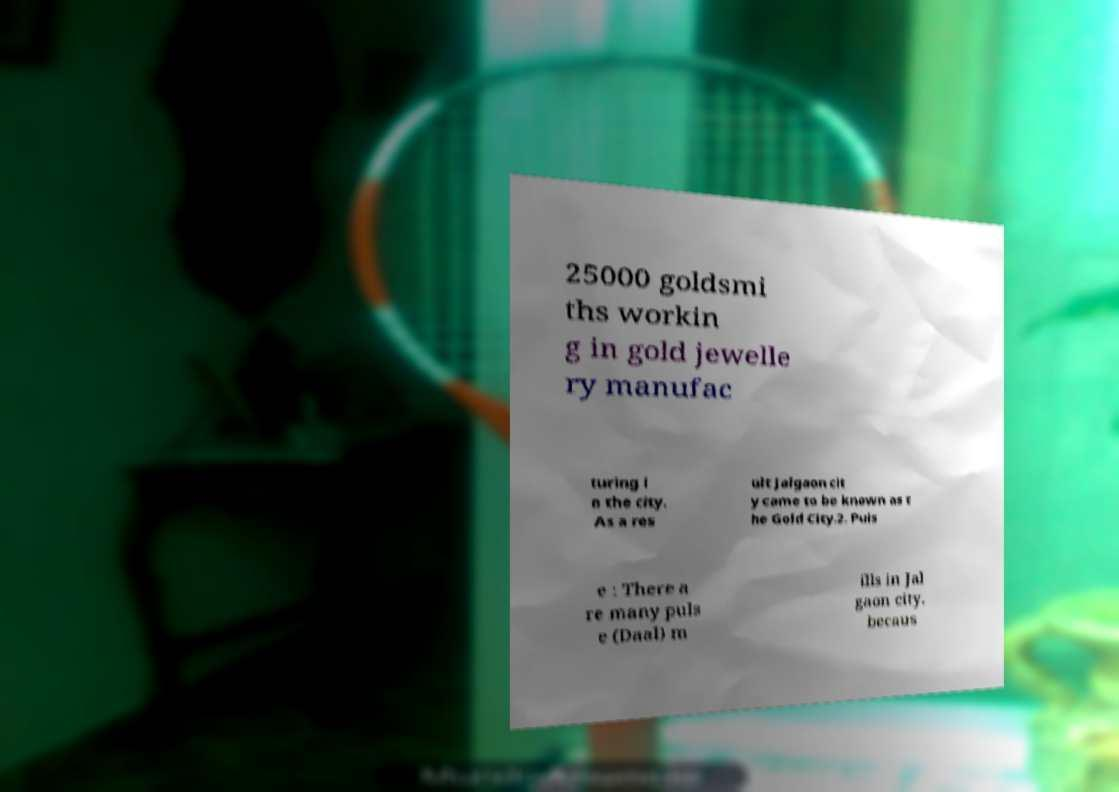Could you assist in decoding the text presented in this image and type it out clearly? 25000 goldsmi ths workin g in gold jewelle ry manufac turing i n the city. As a res ult Jalgaon cit y came to be known as t he Gold City.2. Puls e : There a re many puls e (Daal) m ills in Jal gaon city. becaus 